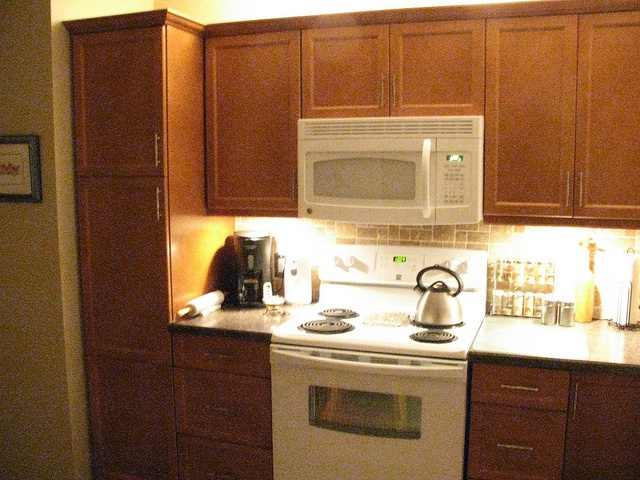Describe the objects in this image and their specific colors. I can see oven in maroon, ivory, gray, and tan tones, microwave in maroon, tan, and gray tones, bottle in maroon, ivory, khaki, and orange tones, bottle in maroon and tan tones, and bottle in maroon and tan tones in this image. 